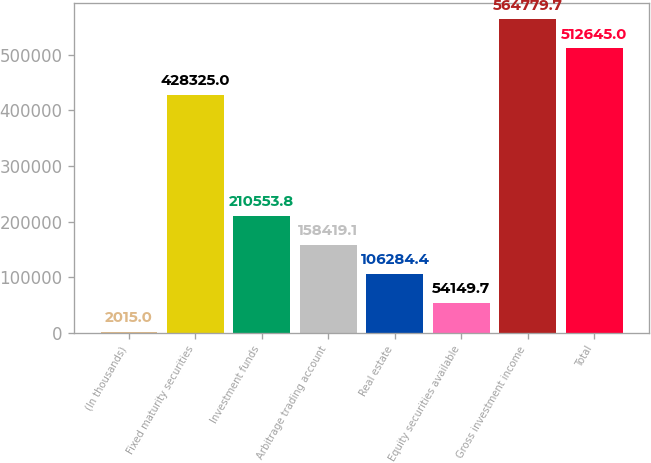<chart> <loc_0><loc_0><loc_500><loc_500><bar_chart><fcel>(In thousands)<fcel>Fixed maturity securities<fcel>Investment funds<fcel>Arbitrage trading account<fcel>Real estate<fcel>Equity securities available<fcel>Gross investment income<fcel>Total<nl><fcel>2015<fcel>428325<fcel>210554<fcel>158419<fcel>106284<fcel>54149.7<fcel>564780<fcel>512645<nl></chart> 